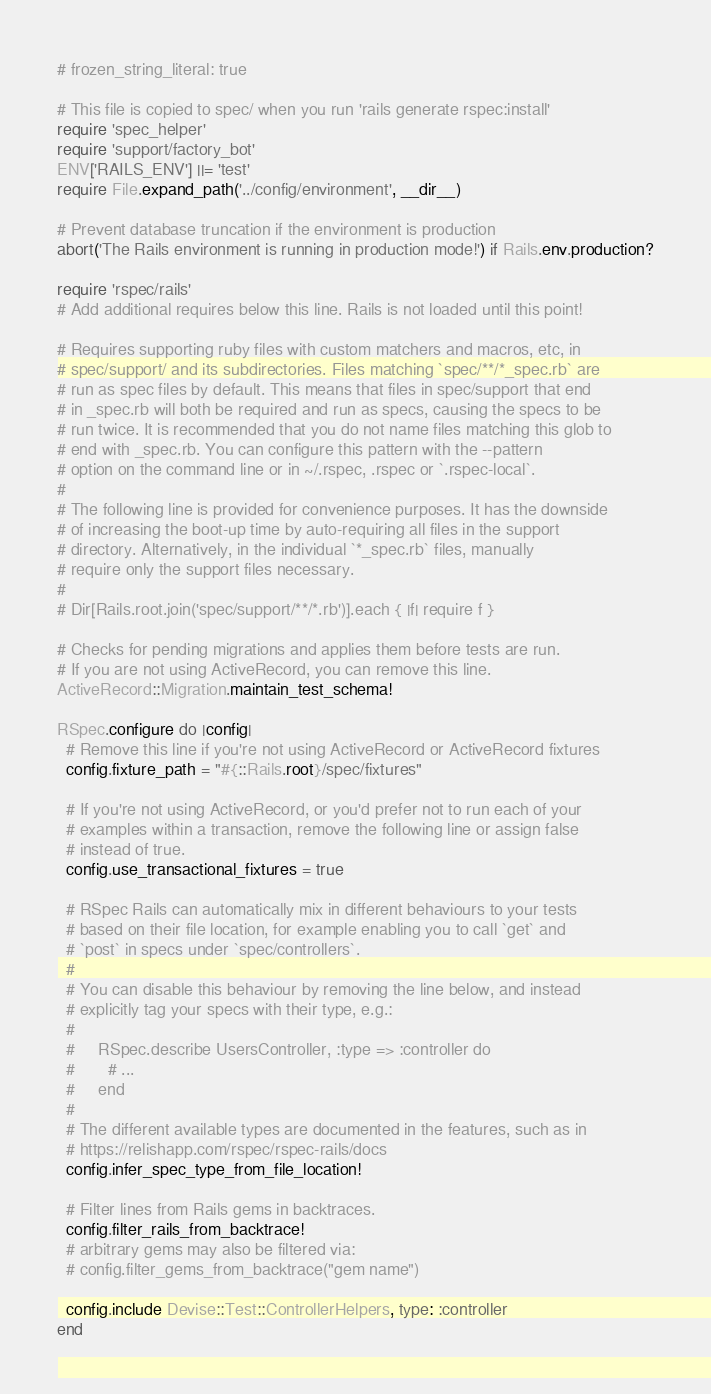<code> <loc_0><loc_0><loc_500><loc_500><_Ruby_># frozen_string_literal: true

# This file is copied to spec/ when you run 'rails generate rspec:install'
require 'spec_helper'
require 'support/factory_bot'
ENV['RAILS_ENV'] ||= 'test'
require File.expand_path('../config/environment', __dir__)

# Prevent database truncation if the environment is production
abort('The Rails environment is running in production mode!') if Rails.env.production?

require 'rspec/rails'
# Add additional requires below this line. Rails is not loaded until this point!

# Requires supporting ruby files with custom matchers and macros, etc, in
# spec/support/ and its subdirectories. Files matching `spec/**/*_spec.rb` are
# run as spec files by default. This means that files in spec/support that end
# in _spec.rb will both be required and run as specs, causing the specs to be
# run twice. It is recommended that you do not name files matching this glob to
# end with _spec.rb. You can configure this pattern with the --pattern
# option on the command line or in ~/.rspec, .rspec or `.rspec-local`.
#
# The following line is provided for convenience purposes. It has the downside
# of increasing the boot-up time by auto-requiring all files in the support
# directory. Alternatively, in the individual `*_spec.rb` files, manually
# require only the support files necessary.
#
# Dir[Rails.root.join('spec/support/**/*.rb')].each { |f| require f }

# Checks for pending migrations and applies them before tests are run.
# If you are not using ActiveRecord, you can remove this line.
ActiveRecord::Migration.maintain_test_schema!

RSpec.configure do |config|
  # Remove this line if you're not using ActiveRecord or ActiveRecord fixtures
  config.fixture_path = "#{::Rails.root}/spec/fixtures"

  # If you're not using ActiveRecord, or you'd prefer not to run each of your
  # examples within a transaction, remove the following line or assign false
  # instead of true.
  config.use_transactional_fixtures = true

  # RSpec Rails can automatically mix in different behaviours to your tests
  # based on their file location, for example enabling you to call `get` and
  # `post` in specs under `spec/controllers`.
  #
  # You can disable this behaviour by removing the line below, and instead
  # explicitly tag your specs with their type, e.g.:
  #
  #     RSpec.describe UsersController, :type => :controller do
  #       # ...
  #     end
  #
  # The different available types are documented in the features, such as in
  # https://relishapp.com/rspec/rspec-rails/docs
  config.infer_spec_type_from_file_location!

  # Filter lines from Rails gems in backtraces.
  config.filter_rails_from_backtrace!
  # arbitrary gems may also be filtered via:
  # config.filter_gems_from_backtrace("gem name")

  config.include Devise::Test::ControllerHelpers, type: :controller
end
</code> 